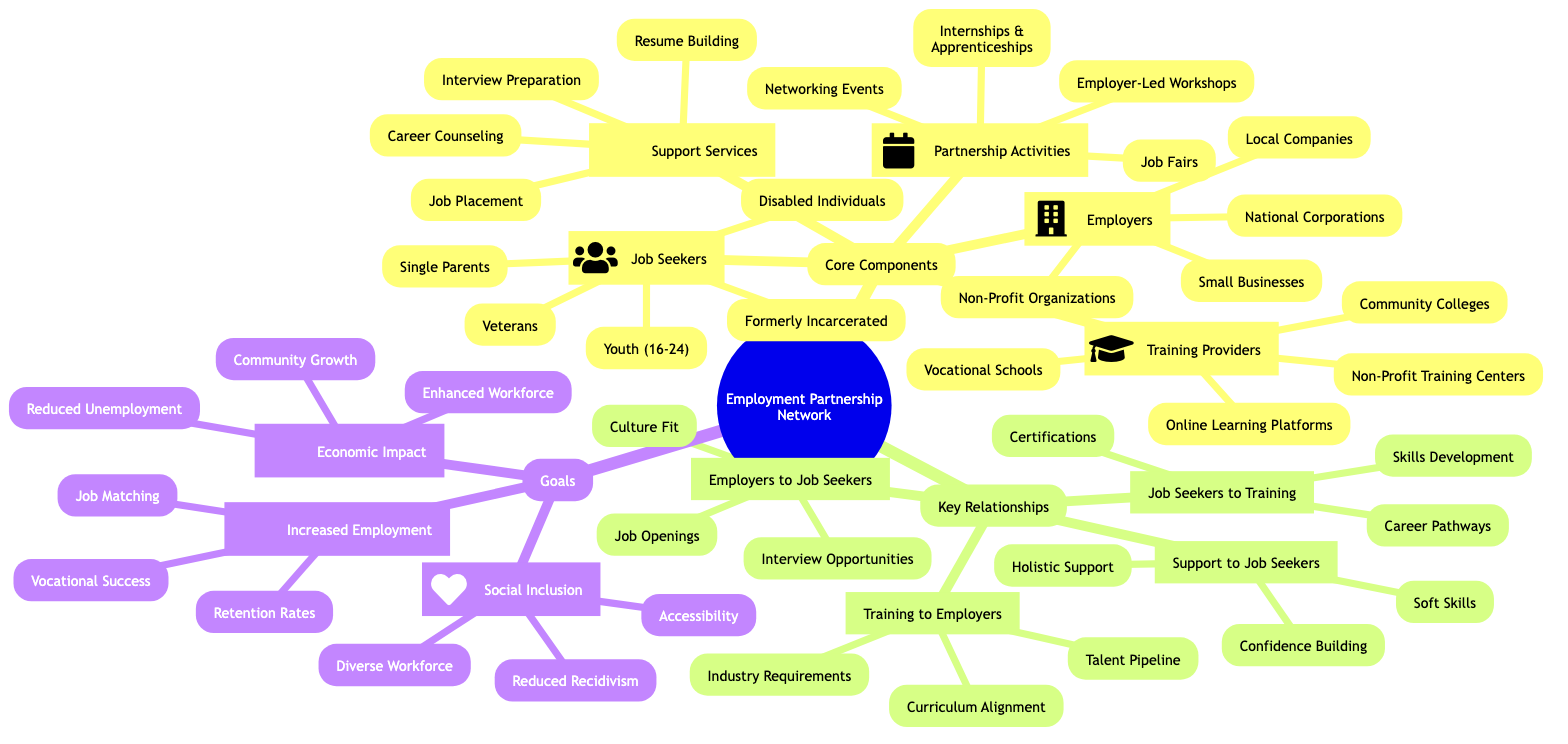What are the four categories of employers in the network? The diagram specifies that there are four categories under "Employers", which are "Local Companies", "National Corporations", "Small Businesses", and "Non-Profit Organizations".
Answer: Local Companies, National Corporations, Small Businesses, Non-Profit Organizations How many types of job seekers are identified? By counting the items listed under "Job Seekers", we find there are five types of job seekers: "Veterans", "Formerly Incarcerated Individuals", "Youth (16-24)", "Single Parents", and "Disabled Individuals".
Answer: 5 What is the primary goal associated with "Increased Employment Rates"? Looking under the "Goals" section, the primary goals listed include "Job Matching", "Retention Rates", and "Vocational Success". The question asks for the first goal, which in the list is "Job Matching".
Answer: Job Matching What relationship do training providers have with employers? The diagram indicates that the relationship between "Training Providers" and "Employers" includes "Curriculum Alignment", "Talent Pipeline", and "Industry Requirements". The question pertains specifically to one of these relationships, which can be determined as "Curriculum Alignment".
Answer: Curriculum Alignment Which job seeker group is specifically mentioned as "Disabled Individuals"? From the "Job Seekers" section, one of the categories is specifically named "Disabled Individuals", which is clearly identified without needing further context.
Answer: Disabled Individuals What type of support does "Support Services" provide specifically to job seekers? Under "Support Services", the roles include "Holistic Support", "Soft Skills Enhancement", and "Confidence Building". These services aim directly to assist job seekers, as demonstrated in the section.
Answer: Holistic Support How many activities are listed under "Partnership Activities"? By reviewing the "Partnership Activities" section, we find that there are four distinct activities: "Job Fairs", "Networking Events", "Employer-Led Workshops", and "Internships and Apprenticeships". Hence, the total number of activities is four.
Answer: 4 